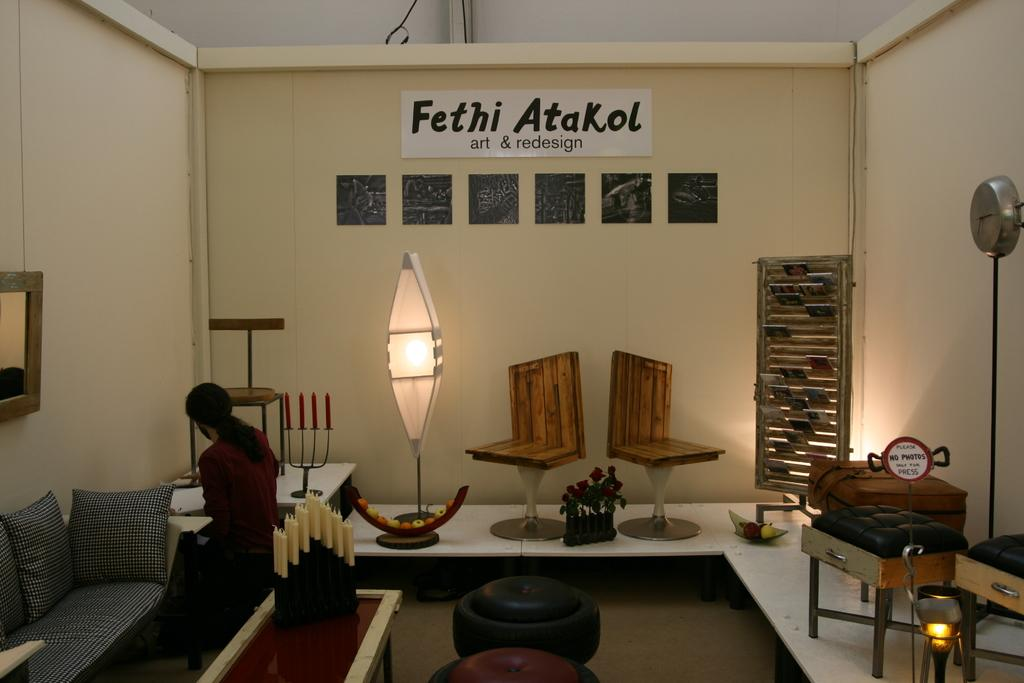<image>
Offer a succinct explanation of the picture presented. Person hanging out in a room with a sign that says "Fethi Atakol" on the top of one wall. 